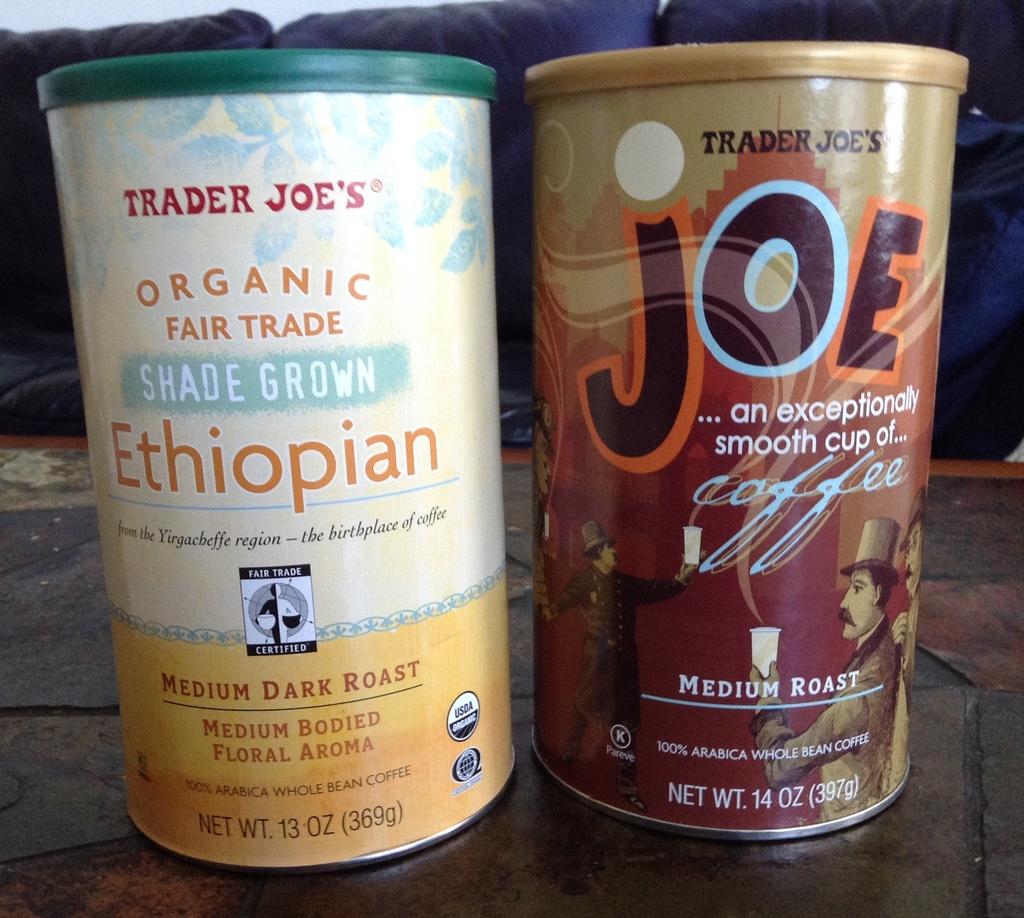How many ounce are in the container of ethiopian coffee?
Provide a succinct answer. 13. What country are the contents of the left can from?
Your answer should be compact. Ethiopia. 